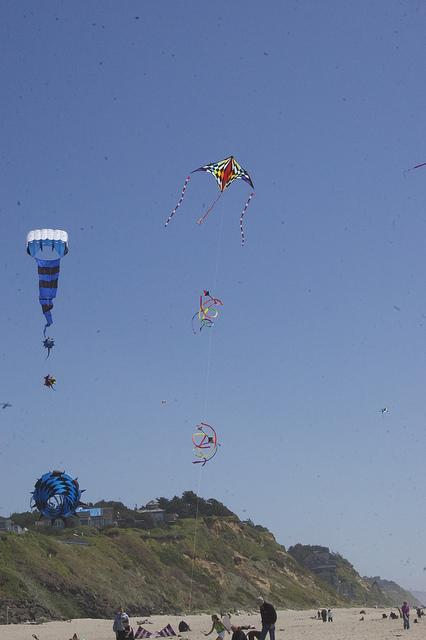What natural disaster are those houses likely safe from?

Choices:
A) win storm
B) dust storm
C) flooding
D) tornado flooding 